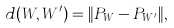<formula> <loc_0><loc_0><loc_500><loc_500>d ( W , W ^ { \prime } ) = \| P _ { W } - P _ { W ^ { \prime } } \| ,</formula> 